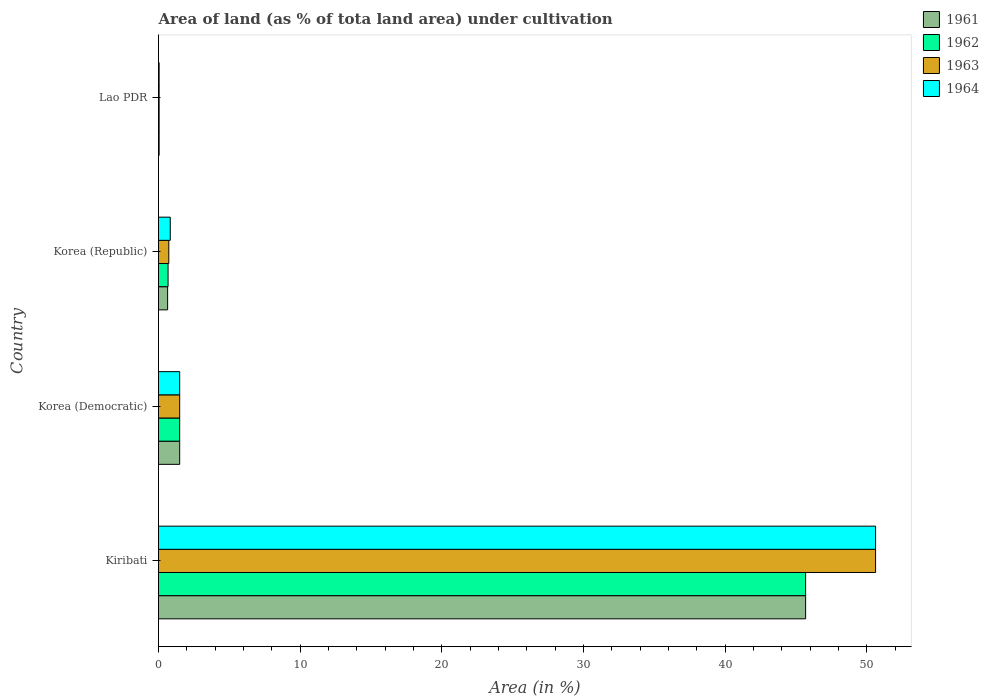How many different coloured bars are there?
Your answer should be compact. 4. How many groups of bars are there?
Provide a succinct answer. 4. Are the number of bars per tick equal to the number of legend labels?
Your answer should be compact. Yes. Are the number of bars on each tick of the Y-axis equal?
Ensure brevity in your answer.  Yes. How many bars are there on the 4th tick from the top?
Make the answer very short. 4. What is the label of the 2nd group of bars from the top?
Your answer should be compact. Korea (Republic). What is the percentage of land under cultivation in 1962 in Lao PDR?
Keep it short and to the point. 0.04. Across all countries, what is the maximum percentage of land under cultivation in 1963?
Keep it short and to the point. 50.62. Across all countries, what is the minimum percentage of land under cultivation in 1962?
Provide a short and direct response. 0.04. In which country was the percentage of land under cultivation in 1962 maximum?
Your answer should be compact. Kiribati. In which country was the percentage of land under cultivation in 1961 minimum?
Provide a short and direct response. Lao PDR. What is the total percentage of land under cultivation in 1961 in the graph?
Provide a short and direct response. 47.86. What is the difference between the percentage of land under cultivation in 1962 in Korea (Democratic) and that in Lao PDR?
Your answer should be very brief. 1.45. What is the difference between the percentage of land under cultivation in 1963 in Korea (Republic) and the percentage of land under cultivation in 1961 in Korea (Democratic)?
Provide a succinct answer. -0.77. What is the average percentage of land under cultivation in 1962 per country?
Your answer should be compact. 11.97. What is the difference between the percentage of land under cultivation in 1961 and percentage of land under cultivation in 1963 in Korea (Republic)?
Keep it short and to the point. -0.08. What is the ratio of the percentage of land under cultivation in 1962 in Korea (Republic) to that in Lao PDR?
Your response must be concise. 15.55. Is the difference between the percentage of land under cultivation in 1961 in Korea (Democratic) and Korea (Republic) greater than the difference between the percentage of land under cultivation in 1963 in Korea (Democratic) and Korea (Republic)?
Your answer should be compact. Yes. What is the difference between the highest and the second highest percentage of land under cultivation in 1962?
Ensure brevity in your answer.  44.18. What is the difference between the highest and the lowest percentage of land under cultivation in 1961?
Offer a very short reply. 45.64. In how many countries, is the percentage of land under cultivation in 1962 greater than the average percentage of land under cultivation in 1962 taken over all countries?
Keep it short and to the point. 1. Is the sum of the percentage of land under cultivation in 1962 in Kiribati and Korea (Democratic) greater than the maximum percentage of land under cultivation in 1963 across all countries?
Offer a terse response. No. What does the 1st bar from the top in Kiribati represents?
Your answer should be compact. 1964. What does the 2nd bar from the bottom in Korea (Republic) represents?
Ensure brevity in your answer.  1962. Is it the case that in every country, the sum of the percentage of land under cultivation in 1962 and percentage of land under cultivation in 1963 is greater than the percentage of land under cultivation in 1964?
Your answer should be very brief. Yes. How many bars are there?
Your answer should be compact. 16. How many countries are there in the graph?
Give a very brief answer. 4. What is the difference between two consecutive major ticks on the X-axis?
Keep it short and to the point. 10. Does the graph contain any zero values?
Your response must be concise. No. How are the legend labels stacked?
Your answer should be compact. Vertical. What is the title of the graph?
Offer a very short reply. Area of land (as % of tota land area) under cultivation. Does "1983" appear as one of the legend labels in the graph?
Your response must be concise. No. What is the label or title of the X-axis?
Your answer should be very brief. Area (in %). What is the Area (in %) of 1961 in Kiribati?
Your response must be concise. 45.68. What is the Area (in %) in 1962 in Kiribati?
Offer a very short reply. 45.68. What is the Area (in %) in 1963 in Kiribati?
Offer a very short reply. 50.62. What is the Area (in %) of 1964 in Kiribati?
Your response must be concise. 50.62. What is the Area (in %) of 1961 in Korea (Democratic)?
Ensure brevity in your answer.  1.49. What is the Area (in %) of 1962 in Korea (Democratic)?
Make the answer very short. 1.49. What is the Area (in %) of 1963 in Korea (Democratic)?
Your answer should be very brief. 1.49. What is the Area (in %) in 1964 in Korea (Democratic)?
Your answer should be very brief. 1.49. What is the Area (in %) of 1961 in Korea (Republic)?
Provide a short and direct response. 0.64. What is the Area (in %) of 1962 in Korea (Republic)?
Provide a succinct answer. 0.67. What is the Area (in %) of 1963 in Korea (Republic)?
Offer a terse response. 0.73. What is the Area (in %) in 1964 in Korea (Republic)?
Provide a succinct answer. 0.83. What is the Area (in %) of 1961 in Lao PDR?
Your answer should be very brief. 0.04. What is the Area (in %) of 1962 in Lao PDR?
Your response must be concise. 0.04. What is the Area (in %) in 1963 in Lao PDR?
Your answer should be compact. 0.04. What is the Area (in %) of 1964 in Lao PDR?
Offer a very short reply. 0.04. Across all countries, what is the maximum Area (in %) in 1961?
Your response must be concise. 45.68. Across all countries, what is the maximum Area (in %) in 1962?
Make the answer very short. 45.68. Across all countries, what is the maximum Area (in %) in 1963?
Ensure brevity in your answer.  50.62. Across all countries, what is the maximum Area (in %) of 1964?
Keep it short and to the point. 50.62. Across all countries, what is the minimum Area (in %) in 1961?
Give a very brief answer. 0.04. Across all countries, what is the minimum Area (in %) in 1962?
Provide a short and direct response. 0.04. Across all countries, what is the minimum Area (in %) in 1963?
Make the answer very short. 0.04. Across all countries, what is the minimum Area (in %) in 1964?
Provide a short and direct response. 0.04. What is the total Area (in %) of 1961 in the graph?
Ensure brevity in your answer.  47.86. What is the total Area (in %) of 1962 in the graph?
Offer a terse response. 47.89. What is the total Area (in %) in 1963 in the graph?
Ensure brevity in your answer.  52.88. What is the total Area (in %) of 1964 in the graph?
Provide a short and direct response. 52.98. What is the difference between the Area (in %) in 1961 in Kiribati and that in Korea (Democratic)?
Keep it short and to the point. 44.18. What is the difference between the Area (in %) in 1962 in Kiribati and that in Korea (Democratic)?
Your answer should be compact. 44.18. What is the difference between the Area (in %) in 1963 in Kiribati and that in Korea (Democratic)?
Your response must be concise. 49.12. What is the difference between the Area (in %) of 1964 in Kiribati and that in Korea (Democratic)?
Make the answer very short. 49.12. What is the difference between the Area (in %) in 1961 in Kiribati and that in Korea (Republic)?
Your answer should be very brief. 45.04. What is the difference between the Area (in %) of 1962 in Kiribati and that in Korea (Republic)?
Ensure brevity in your answer.  45.01. What is the difference between the Area (in %) of 1963 in Kiribati and that in Korea (Republic)?
Your answer should be compact. 49.89. What is the difference between the Area (in %) of 1964 in Kiribati and that in Korea (Republic)?
Provide a short and direct response. 49.79. What is the difference between the Area (in %) in 1961 in Kiribati and that in Lao PDR?
Provide a short and direct response. 45.64. What is the difference between the Area (in %) in 1962 in Kiribati and that in Lao PDR?
Your answer should be very brief. 45.64. What is the difference between the Area (in %) of 1963 in Kiribati and that in Lao PDR?
Make the answer very short. 50.57. What is the difference between the Area (in %) in 1964 in Kiribati and that in Lao PDR?
Give a very brief answer. 50.57. What is the difference between the Area (in %) of 1961 in Korea (Democratic) and that in Korea (Republic)?
Keep it short and to the point. 0.85. What is the difference between the Area (in %) in 1962 in Korea (Democratic) and that in Korea (Republic)?
Give a very brief answer. 0.82. What is the difference between the Area (in %) in 1963 in Korea (Democratic) and that in Korea (Republic)?
Your answer should be very brief. 0.77. What is the difference between the Area (in %) of 1964 in Korea (Democratic) and that in Korea (Republic)?
Give a very brief answer. 0.67. What is the difference between the Area (in %) of 1961 in Korea (Democratic) and that in Lao PDR?
Provide a short and direct response. 1.45. What is the difference between the Area (in %) of 1962 in Korea (Democratic) and that in Lao PDR?
Your response must be concise. 1.45. What is the difference between the Area (in %) of 1963 in Korea (Democratic) and that in Lao PDR?
Your answer should be very brief. 1.45. What is the difference between the Area (in %) in 1964 in Korea (Democratic) and that in Lao PDR?
Your answer should be very brief. 1.45. What is the difference between the Area (in %) in 1961 in Korea (Republic) and that in Lao PDR?
Your answer should be compact. 0.6. What is the difference between the Area (in %) in 1962 in Korea (Republic) and that in Lao PDR?
Offer a terse response. 0.63. What is the difference between the Area (in %) of 1963 in Korea (Republic) and that in Lao PDR?
Make the answer very short. 0.68. What is the difference between the Area (in %) of 1964 in Korea (Republic) and that in Lao PDR?
Your answer should be very brief. 0.79. What is the difference between the Area (in %) in 1961 in Kiribati and the Area (in %) in 1962 in Korea (Democratic)?
Provide a short and direct response. 44.18. What is the difference between the Area (in %) in 1961 in Kiribati and the Area (in %) in 1963 in Korea (Democratic)?
Give a very brief answer. 44.18. What is the difference between the Area (in %) of 1961 in Kiribati and the Area (in %) of 1964 in Korea (Democratic)?
Provide a short and direct response. 44.18. What is the difference between the Area (in %) in 1962 in Kiribati and the Area (in %) in 1963 in Korea (Democratic)?
Your response must be concise. 44.18. What is the difference between the Area (in %) in 1962 in Kiribati and the Area (in %) in 1964 in Korea (Democratic)?
Offer a very short reply. 44.18. What is the difference between the Area (in %) of 1963 in Kiribati and the Area (in %) of 1964 in Korea (Democratic)?
Make the answer very short. 49.12. What is the difference between the Area (in %) in 1961 in Kiribati and the Area (in %) in 1962 in Korea (Republic)?
Your response must be concise. 45.01. What is the difference between the Area (in %) in 1961 in Kiribati and the Area (in %) in 1963 in Korea (Republic)?
Offer a very short reply. 44.95. What is the difference between the Area (in %) of 1961 in Kiribati and the Area (in %) of 1964 in Korea (Republic)?
Offer a very short reply. 44.85. What is the difference between the Area (in %) of 1962 in Kiribati and the Area (in %) of 1963 in Korea (Republic)?
Ensure brevity in your answer.  44.95. What is the difference between the Area (in %) of 1962 in Kiribati and the Area (in %) of 1964 in Korea (Republic)?
Give a very brief answer. 44.85. What is the difference between the Area (in %) in 1963 in Kiribati and the Area (in %) in 1964 in Korea (Republic)?
Your answer should be compact. 49.79. What is the difference between the Area (in %) in 1961 in Kiribati and the Area (in %) in 1962 in Lao PDR?
Your answer should be very brief. 45.64. What is the difference between the Area (in %) in 1961 in Kiribati and the Area (in %) in 1963 in Lao PDR?
Provide a short and direct response. 45.64. What is the difference between the Area (in %) in 1961 in Kiribati and the Area (in %) in 1964 in Lao PDR?
Offer a terse response. 45.64. What is the difference between the Area (in %) of 1962 in Kiribati and the Area (in %) of 1963 in Lao PDR?
Make the answer very short. 45.64. What is the difference between the Area (in %) of 1962 in Kiribati and the Area (in %) of 1964 in Lao PDR?
Ensure brevity in your answer.  45.64. What is the difference between the Area (in %) of 1963 in Kiribati and the Area (in %) of 1964 in Lao PDR?
Your answer should be compact. 50.57. What is the difference between the Area (in %) of 1961 in Korea (Democratic) and the Area (in %) of 1962 in Korea (Republic)?
Your response must be concise. 0.82. What is the difference between the Area (in %) in 1961 in Korea (Democratic) and the Area (in %) in 1963 in Korea (Republic)?
Make the answer very short. 0.77. What is the difference between the Area (in %) of 1961 in Korea (Democratic) and the Area (in %) of 1964 in Korea (Republic)?
Keep it short and to the point. 0.67. What is the difference between the Area (in %) of 1962 in Korea (Democratic) and the Area (in %) of 1963 in Korea (Republic)?
Your answer should be very brief. 0.77. What is the difference between the Area (in %) of 1962 in Korea (Democratic) and the Area (in %) of 1964 in Korea (Republic)?
Offer a terse response. 0.67. What is the difference between the Area (in %) of 1963 in Korea (Democratic) and the Area (in %) of 1964 in Korea (Republic)?
Provide a short and direct response. 0.67. What is the difference between the Area (in %) of 1961 in Korea (Democratic) and the Area (in %) of 1962 in Lao PDR?
Offer a very short reply. 1.45. What is the difference between the Area (in %) in 1961 in Korea (Democratic) and the Area (in %) in 1963 in Lao PDR?
Offer a very short reply. 1.45. What is the difference between the Area (in %) of 1961 in Korea (Democratic) and the Area (in %) of 1964 in Lao PDR?
Provide a short and direct response. 1.45. What is the difference between the Area (in %) in 1962 in Korea (Democratic) and the Area (in %) in 1963 in Lao PDR?
Your answer should be very brief. 1.45. What is the difference between the Area (in %) in 1962 in Korea (Democratic) and the Area (in %) in 1964 in Lao PDR?
Make the answer very short. 1.45. What is the difference between the Area (in %) in 1963 in Korea (Democratic) and the Area (in %) in 1964 in Lao PDR?
Provide a succinct answer. 1.45. What is the difference between the Area (in %) of 1961 in Korea (Republic) and the Area (in %) of 1962 in Lao PDR?
Your answer should be compact. 0.6. What is the difference between the Area (in %) in 1961 in Korea (Republic) and the Area (in %) in 1963 in Lao PDR?
Ensure brevity in your answer.  0.6. What is the difference between the Area (in %) of 1961 in Korea (Republic) and the Area (in %) of 1964 in Lao PDR?
Offer a very short reply. 0.6. What is the difference between the Area (in %) of 1962 in Korea (Republic) and the Area (in %) of 1963 in Lao PDR?
Your response must be concise. 0.63. What is the difference between the Area (in %) of 1962 in Korea (Republic) and the Area (in %) of 1964 in Lao PDR?
Give a very brief answer. 0.63. What is the difference between the Area (in %) of 1963 in Korea (Republic) and the Area (in %) of 1964 in Lao PDR?
Keep it short and to the point. 0.68. What is the average Area (in %) of 1961 per country?
Give a very brief answer. 11.96. What is the average Area (in %) in 1962 per country?
Offer a terse response. 11.97. What is the average Area (in %) of 1963 per country?
Your answer should be compact. 13.22. What is the average Area (in %) of 1964 per country?
Your answer should be compact. 13.25. What is the difference between the Area (in %) of 1961 and Area (in %) of 1963 in Kiribati?
Ensure brevity in your answer.  -4.94. What is the difference between the Area (in %) in 1961 and Area (in %) in 1964 in Kiribati?
Offer a terse response. -4.94. What is the difference between the Area (in %) in 1962 and Area (in %) in 1963 in Kiribati?
Ensure brevity in your answer.  -4.94. What is the difference between the Area (in %) in 1962 and Area (in %) in 1964 in Kiribati?
Your answer should be very brief. -4.94. What is the difference between the Area (in %) of 1963 and Area (in %) of 1964 in Kiribati?
Your response must be concise. 0. What is the difference between the Area (in %) in 1961 and Area (in %) in 1963 in Korea (Democratic)?
Provide a short and direct response. 0. What is the difference between the Area (in %) of 1961 and Area (in %) of 1964 in Korea (Democratic)?
Make the answer very short. 0. What is the difference between the Area (in %) of 1962 and Area (in %) of 1964 in Korea (Democratic)?
Your answer should be compact. 0. What is the difference between the Area (in %) of 1961 and Area (in %) of 1962 in Korea (Republic)?
Your answer should be very brief. -0.03. What is the difference between the Area (in %) of 1961 and Area (in %) of 1963 in Korea (Republic)?
Provide a short and direct response. -0.08. What is the difference between the Area (in %) in 1961 and Area (in %) in 1964 in Korea (Republic)?
Offer a terse response. -0.19. What is the difference between the Area (in %) in 1962 and Area (in %) in 1963 in Korea (Republic)?
Your answer should be very brief. -0.05. What is the difference between the Area (in %) of 1962 and Area (in %) of 1964 in Korea (Republic)?
Give a very brief answer. -0.16. What is the difference between the Area (in %) of 1963 and Area (in %) of 1964 in Korea (Republic)?
Give a very brief answer. -0.1. What is the difference between the Area (in %) of 1962 and Area (in %) of 1964 in Lao PDR?
Your response must be concise. 0. What is the difference between the Area (in %) of 1963 and Area (in %) of 1964 in Lao PDR?
Provide a succinct answer. 0. What is the ratio of the Area (in %) of 1961 in Kiribati to that in Korea (Democratic)?
Provide a short and direct response. 30.56. What is the ratio of the Area (in %) in 1962 in Kiribati to that in Korea (Democratic)?
Provide a short and direct response. 30.56. What is the ratio of the Area (in %) in 1963 in Kiribati to that in Korea (Democratic)?
Your response must be concise. 33.86. What is the ratio of the Area (in %) of 1964 in Kiribati to that in Korea (Democratic)?
Keep it short and to the point. 33.86. What is the ratio of the Area (in %) of 1961 in Kiribati to that in Korea (Republic)?
Offer a very short reply. 71.07. What is the ratio of the Area (in %) of 1962 in Kiribati to that in Korea (Republic)?
Offer a very short reply. 67.79. What is the ratio of the Area (in %) in 1963 in Kiribati to that in Korea (Republic)?
Ensure brevity in your answer.  69.75. What is the ratio of the Area (in %) of 1964 in Kiribati to that in Korea (Republic)?
Keep it short and to the point. 61.03. What is the ratio of the Area (in %) of 1961 in Kiribati to that in Lao PDR?
Your answer should be very brief. 1054.27. What is the ratio of the Area (in %) in 1962 in Kiribati to that in Lao PDR?
Provide a short and direct response. 1054.27. What is the ratio of the Area (in %) of 1963 in Kiribati to that in Lao PDR?
Offer a terse response. 1168.25. What is the ratio of the Area (in %) of 1964 in Kiribati to that in Lao PDR?
Provide a succinct answer. 1168.25. What is the ratio of the Area (in %) of 1961 in Korea (Democratic) to that in Korea (Republic)?
Provide a succinct answer. 2.33. What is the ratio of the Area (in %) in 1962 in Korea (Democratic) to that in Korea (Republic)?
Provide a short and direct response. 2.22. What is the ratio of the Area (in %) in 1963 in Korea (Democratic) to that in Korea (Republic)?
Your response must be concise. 2.06. What is the ratio of the Area (in %) in 1964 in Korea (Democratic) to that in Korea (Republic)?
Keep it short and to the point. 1.8. What is the ratio of the Area (in %) in 1961 in Korea (Democratic) to that in Lao PDR?
Your answer should be compact. 34.5. What is the ratio of the Area (in %) in 1962 in Korea (Democratic) to that in Lao PDR?
Your answer should be compact. 34.5. What is the ratio of the Area (in %) of 1963 in Korea (Democratic) to that in Lao PDR?
Give a very brief answer. 34.5. What is the ratio of the Area (in %) of 1964 in Korea (Democratic) to that in Lao PDR?
Ensure brevity in your answer.  34.5. What is the ratio of the Area (in %) of 1961 in Korea (Republic) to that in Lao PDR?
Make the answer very short. 14.83. What is the ratio of the Area (in %) of 1962 in Korea (Republic) to that in Lao PDR?
Your answer should be very brief. 15.55. What is the ratio of the Area (in %) in 1963 in Korea (Republic) to that in Lao PDR?
Offer a very short reply. 16.75. What is the ratio of the Area (in %) of 1964 in Korea (Republic) to that in Lao PDR?
Provide a short and direct response. 19.14. What is the difference between the highest and the second highest Area (in %) of 1961?
Your answer should be very brief. 44.18. What is the difference between the highest and the second highest Area (in %) in 1962?
Provide a short and direct response. 44.18. What is the difference between the highest and the second highest Area (in %) of 1963?
Your response must be concise. 49.12. What is the difference between the highest and the second highest Area (in %) of 1964?
Provide a short and direct response. 49.12. What is the difference between the highest and the lowest Area (in %) of 1961?
Provide a succinct answer. 45.64. What is the difference between the highest and the lowest Area (in %) of 1962?
Offer a terse response. 45.64. What is the difference between the highest and the lowest Area (in %) in 1963?
Offer a terse response. 50.57. What is the difference between the highest and the lowest Area (in %) in 1964?
Your answer should be very brief. 50.57. 